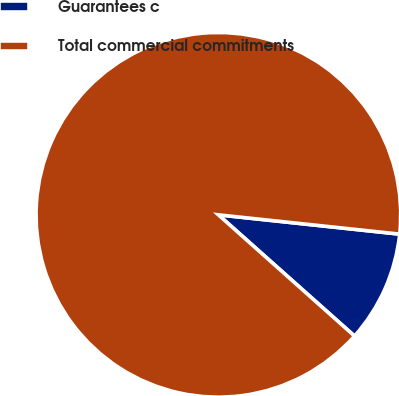<chart> <loc_0><loc_0><loc_500><loc_500><pie_chart><fcel>Guarantees c<fcel>Total commercial commitments<nl><fcel>9.89%<fcel>90.11%<nl></chart> 